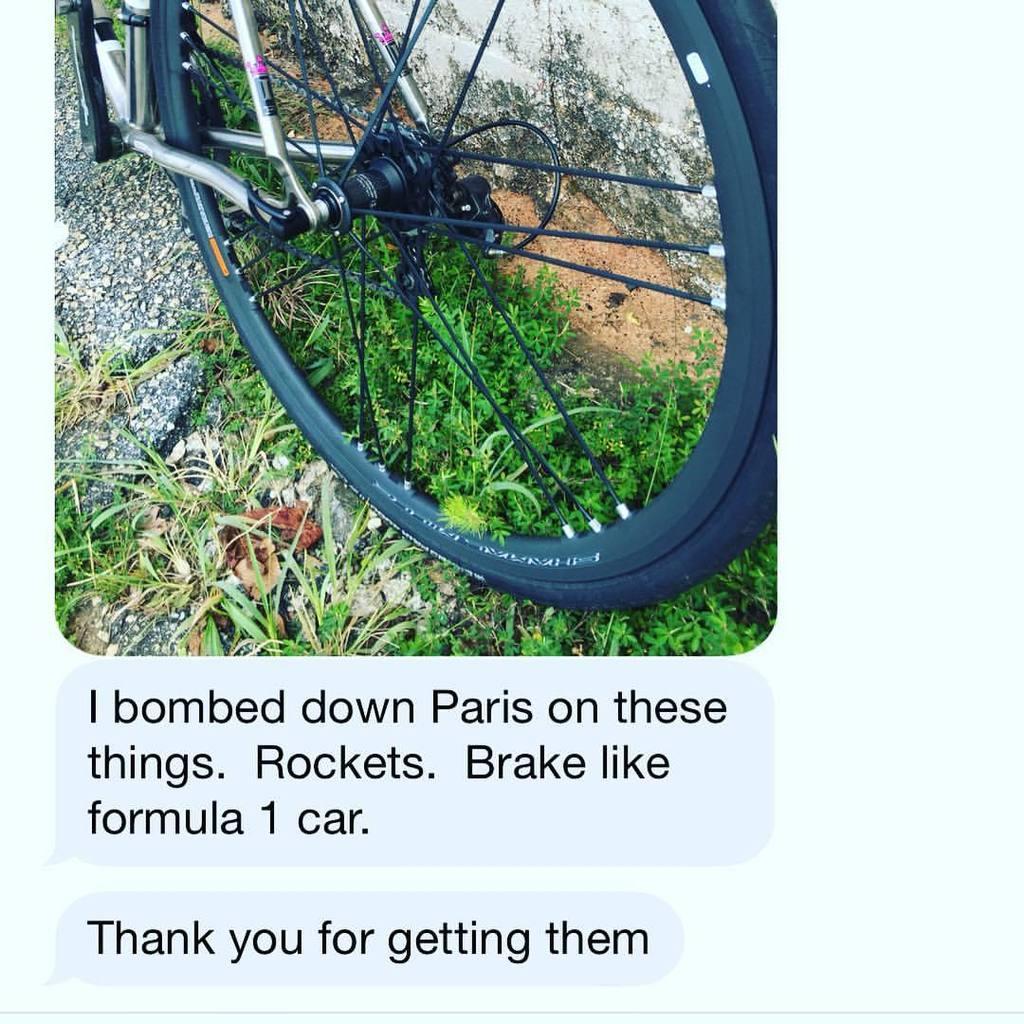Please provide a concise description of this image. In this image, we can see a wheel and some plants beside the wall. There is a text at the bottom of the image. 